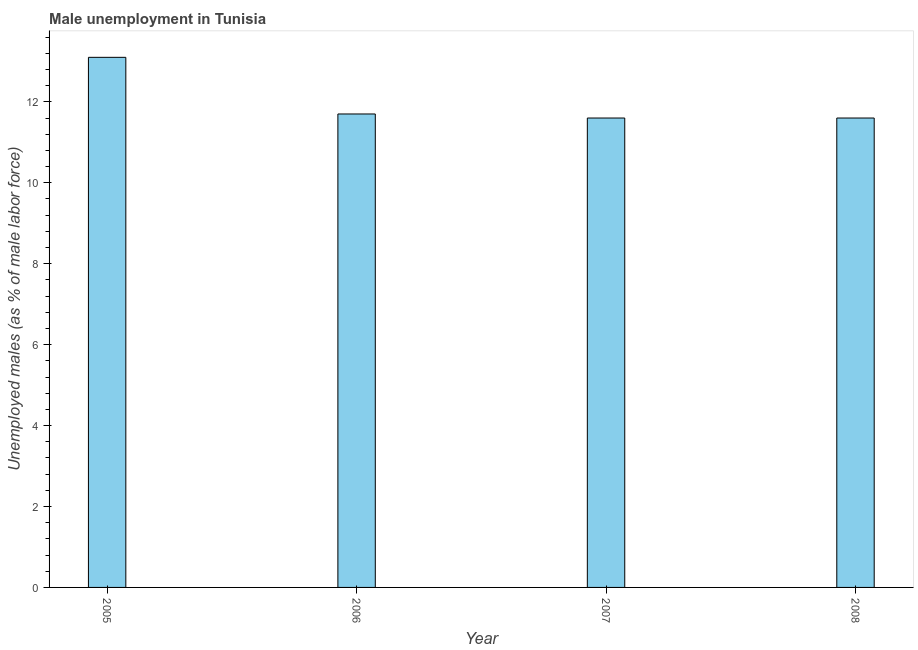Does the graph contain any zero values?
Ensure brevity in your answer.  No. What is the title of the graph?
Your answer should be compact. Male unemployment in Tunisia. What is the label or title of the X-axis?
Make the answer very short. Year. What is the label or title of the Y-axis?
Give a very brief answer. Unemployed males (as % of male labor force). What is the unemployed males population in 2005?
Offer a terse response. 13.1. Across all years, what is the maximum unemployed males population?
Your response must be concise. 13.1. Across all years, what is the minimum unemployed males population?
Give a very brief answer. 11.6. In which year was the unemployed males population minimum?
Offer a very short reply. 2007. What is the sum of the unemployed males population?
Ensure brevity in your answer.  48. What is the average unemployed males population per year?
Offer a very short reply. 12. What is the median unemployed males population?
Offer a terse response. 11.65. What is the ratio of the unemployed males population in 2007 to that in 2008?
Keep it short and to the point. 1. What is the difference between the highest and the lowest unemployed males population?
Make the answer very short. 1.5. In how many years, is the unemployed males population greater than the average unemployed males population taken over all years?
Offer a very short reply. 1. How many bars are there?
Offer a very short reply. 4. How many years are there in the graph?
Provide a succinct answer. 4. What is the Unemployed males (as % of male labor force) of 2005?
Give a very brief answer. 13.1. What is the Unemployed males (as % of male labor force) in 2006?
Provide a short and direct response. 11.7. What is the Unemployed males (as % of male labor force) of 2007?
Make the answer very short. 11.6. What is the Unemployed males (as % of male labor force) of 2008?
Offer a terse response. 11.6. What is the difference between the Unemployed males (as % of male labor force) in 2005 and 2008?
Give a very brief answer. 1.5. What is the difference between the Unemployed males (as % of male labor force) in 2006 and 2008?
Make the answer very short. 0.1. What is the difference between the Unemployed males (as % of male labor force) in 2007 and 2008?
Give a very brief answer. 0. What is the ratio of the Unemployed males (as % of male labor force) in 2005 to that in 2006?
Your answer should be compact. 1.12. What is the ratio of the Unemployed males (as % of male labor force) in 2005 to that in 2007?
Keep it short and to the point. 1.13. What is the ratio of the Unemployed males (as % of male labor force) in 2005 to that in 2008?
Your answer should be very brief. 1.13. What is the ratio of the Unemployed males (as % of male labor force) in 2006 to that in 2008?
Offer a terse response. 1.01. 